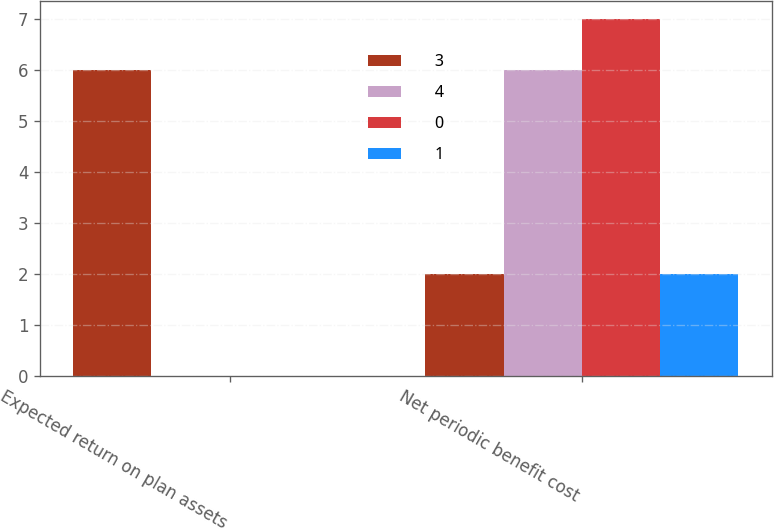Convert chart to OTSL. <chart><loc_0><loc_0><loc_500><loc_500><stacked_bar_chart><ecel><fcel>Expected return on plan assets<fcel>Net periodic benefit cost<nl><fcel>3<fcel>6<fcel>2<nl><fcel>4<fcel>0<fcel>6<nl><fcel>0<fcel>0<fcel>7<nl><fcel>1<fcel>0<fcel>2<nl></chart> 